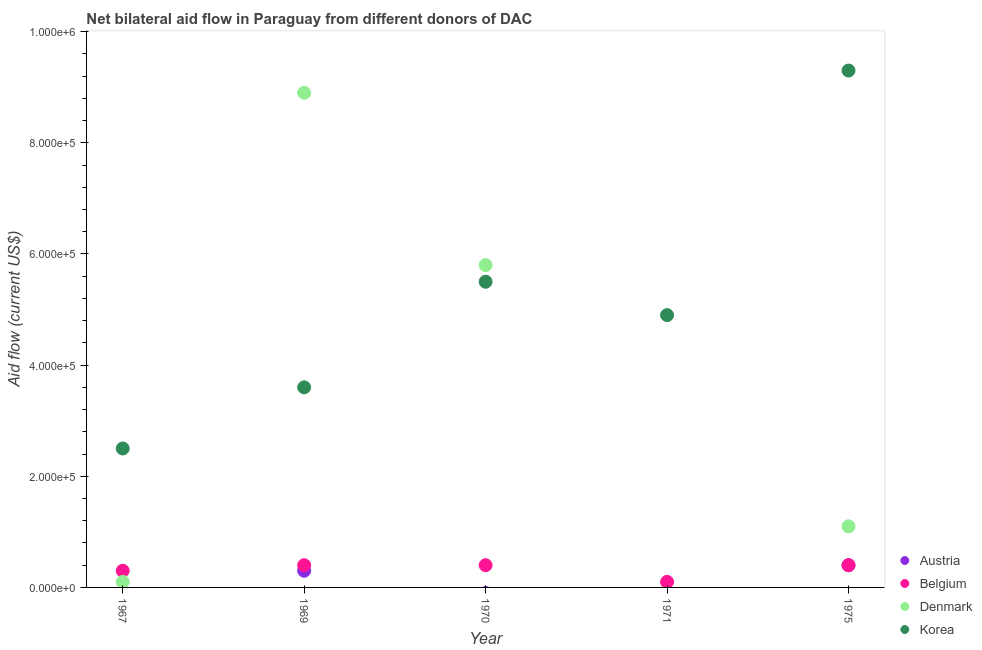What is the amount of aid given by denmark in 1967?
Keep it short and to the point. 10000. Across all years, what is the maximum amount of aid given by denmark?
Your answer should be compact. 8.90e+05. Across all years, what is the minimum amount of aid given by austria?
Keep it short and to the point. 0. In which year was the amount of aid given by denmark maximum?
Ensure brevity in your answer.  1969. What is the total amount of aid given by korea in the graph?
Provide a succinct answer. 2.58e+06. What is the difference between the amount of aid given by belgium in 1967 and that in 1975?
Offer a terse response. -10000. What is the difference between the amount of aid given by denmark in 1970 and the amount of aid given by belgium in 1971?
Ensure brevity in your answer.  5.70e+05. What is the average amount of aid given by korea per year?
Provide a succinct answer. 5.16e+05. In the year 1971, what is the difference between the amount of aid given by korea and amount of aid given by belgium?
Give a very brief answer. 4.80e+05. What is the ratio of the amount of aid given by denmark in 1969 to that in 1970?
Give a very brief answer. 1.53. Is the amount of aid given by belgium in 1969 less than that in 1971?
Your response must be concise. No. What is the difference between the highest and the lowest amount of aid given by denmark?
Keep it short and to the point. 8.90e+05. In how many years, is the amount of aid given by korea greater than the average amount of aid given by korea taken over all years?
Keep it short and to the point. 2. Is the sum of the amount of aid given by denmark in 1967 and 1975 greater than the maximum amount of aid given by korea across all years?
Provide a short and direct response. No. Is it the case that in every year, the sum of the amount of aid given by korea and amount of aid given by belgium is greater than the sum of amount of aid given by austria and amount of aid given by denmark?
Give a very brief answer. Yes. Is it the case that in every year, the sum of the amount of aid given by austria and amount of aid given by belgium is greater than the amount of aid given by denmark?
Your answer should be compact. No. Does the amount of aid given by korea monotonically increase over the years?
Provide a succinct answer. No. Are the values on the major ticks of Y-axis written in scientific E-notation?
Keep it short and to the point. Yes. Does the graph contain any zero values?
Provide a succinct answer. Yes. How many legend labels are there?
Provide a succinct answer. 4. What is the title of the graph?
Provide a short and direct response. Net bilateral aid flow in Paraguay from different donors of DAC. Does "Switzerland" appear as one of the legend labels in the graph?
Provide a short and direct response. No. What is the label or title of the Y-axis?
Provide a succinct answer. Aid flow (current US$). What is the Aid flow (current US$) in Denmark in 1969?
Your response must be concise. 8.90e+05. What is the Aid flow (current US$) of Korea in 1969?
Give a very brief answer. 3.60e+05. What is the Aid flow (current US$) in Belgium in 1970?
Ensure brevity in your answer.  4.00e+04. What is the Aid flow (current US$) in Denmark in 1970?
Provide a short and direct response. 5.80e+05. What is the Aid flow (current US$) of Korea in 1970?
Your answer should be very brief. 5.50e+05. What is the Aid flow (current US$) in Austria in 1971?
Offer a terse response. 0. What is the Aid flow (current US$) of Austria in 1975?
Your response must be concise. 4.00e+04. What is the Aid flow (current US$) in Belgium in 1975?
Offer a terse response. 4.00e+04. What is the Aid flow (current US$) of Denmark in 1975?
Provide a succinct answer. 1.10e+05. What is the Aid flow (current US$) of Korea in 1975?
Your answer should be compact. 9.30e+05. Across all years, what is the maximum Aid flow (current US$) of Denmark?
Give a very brief answer. 8.90e+05. Across all years, what is the maximum Aid flow (current US$) in Korea?
Your response must be concise. 9.30e+05. Across all years, what is the minimum Aid flow (current US$) in Austria?
Ensure brevity in your answer.  0. Across all years, what is the minimum Aid flow (current US$) in Belgium?
Offer a terse response. 10000. What is the total Aid flow (current US$) in Austria in the graph?
Give a very brief answer. 7.00e+04. What is the total Aid flow (current US$) of Denmark in the graph?
Provide a succinct answer. 1.59e+06. What is the total Aid flow (current US$) in Korea in the graph?
Ensure brevity in your answer.  2.58e+06. What is the difference between the Aid flow (current US$) of Belgium in 1967 and that in 1969?
Your answer should be compact. -10000. What is the difference between the Aid flow (current US$) in Denmark in 1967 and that in 1969?
Your answer should be compact. -8.80e+05. What is the difference between the Aid flow (current US$) of Belgium in 1967 and that in 1970?
Offer a terse response. -10000. What is the difference between the Aid flow (current US$) of Denmark in 1967 and that in 1970?
Make the answer very short. -5.70e+05. What is the difference between the Aid flow (current US$) in Belgium in 1967 and that in 1971?
Ensure brevity in your answer.  2.00e+04. What is the difference between the Aid flow (current US$) of Korea in 1967 and that in 1971?
Ensure brevity in your answer.  -2.40e+05. What is the difference between the Aid flow (current US$) in Belgium in 1967 and that in 1975?
Keep it short and to the point. -10000. What is the difference between the Aid flow (current US$) in Denmark in 1967 and that in 1975?
Provide a succinct answer. -1.00e+05. What is the difference between the Aid flow (current US$) of Korea in 1967 and that in 1975?
Your answer should be compact. -6.80e+05. What is the difference between the Aid flow (current US$) in Belgium in 1969 and that in 1970?
Your answer should be very brief. 0. What is the difference between the Aid flow (current US$) in Denmark in 1969 and that in 1970?
Your answer should be very brief. 3.10e+05. What is the difference between the Aid flow (current US$) in Austria in 1969 and that in 1975?
Ensure brevity in your answer.  -10000. What is the difference between the Aid flow (current US$) in Denmark in 1969 and that in 1975?
Your response must be concise. 7.80e+05. What is the difference between the Aid flow (current US$) in Korea in 1969 and that in 1975?
Offer a terse response. -5.70e+05. What is the difference between the Aid flow (current US$) of Denmark in 1970 and that in 1975?
Keep it short and to the point. 4.70e+05. What is the difference between the Aid flow (current US$) in Korea in 1970 and that in 1975?
Ensure brevity in your answer.  -3.80e+05. What is the difference between the Aid flow (current US$) in Korea in 1971 and that in 1975?
Give a very brief answer. -4.40e+05. What is the difference between the Aid flow (current US$) of Belgium in 1967 and the Aid flow (current US$) of Denmark in 1969?
Keep it short and to the point. -8.60e+05. What is the difference between the Aid flow (current US$) of Belgium in 1967 and the Aid flow (current US$) of Korea in 1969?
Your answer should be compact. -3.30e+05. What is the difference between the Aid flow (current US$) of Denmark in 1967 and the Aid flow (current US$) of Korea in 1969?
Make the answer very short. -3.50e+05. What is the difference between the Aid flow (current US$) in Belgium in 1967 and the Aid flow (current US$) in Denmark in 1970?
Give a very brief answer. -5.50e+05. What is the difference between the Aid flow (current US$) of Belgium in 1967 and the Aid flow (current US$) of Korea in 1970?
Make the answer very short. -5.20e+05. What is the difference between the Aid flow (current US$) of Denmark in 1967 and the Aid flow (current US$) of Korea in 1970?
Keep it short and to the point. -5.40e+05. What is the difference between the Aid flow (current US$) in Belgium in 1967 and the Aid flow (current US$) in Korea in 1971?
Your answer should be very brief. -4.60e+05. What is the difference between the Aid flow (current US$) of Denmark in 1967 and the Aid flow (current US$) of Korea in 1971?
Make the answer very short. -4.80e+05. What is the difference between the Aid flow (current US$) in Belgium in 1967 and the Aid flow (current US$) in Korea in 1975?
Ensure brevity in your answer.  -9.00e+05. What is the difference between the Aid flow (current US$) in Denmark in 1967 and the Aid flow (current US$) in Korea in 1975?
Your answer should be compact. -9.20e+05. What is the difference between the Aid flow (current US$) in Austria in 1969 and the Aid flow (current US$) in Belgium in 1970?
Provide a succinct answer. -10000. What is the difference between the Aid flow (current US$) in Austria in 1969 and the Aid flow (current US$) in Denmark in 1970?
Make the answer very short. -5.50e+05. What is the difference between the Aid flow (current US$) in Austria in 1969 and the Aid flow (current US$) in Korea in 1970?
Keep it short and to the point. -5.20e+05. What is the difference between the Aid flow (current US$) of Belgium in 1969 and the Aid flow (current US$) of Denmark in 1970?
Give a very brief answer. -5.40e+05. What is the difference between the Aid flow (current US$) in Belgium in 1969 and the Aid flow (current US$) in Korea in 1970?
Offer a very short reply. -5.10e+05. What is the difference between the Aid flow (current US$) of Denmark in 1969 and the Aid flow (current US$) of Korea in 1970?
Make the answer very short. 3.40e+05. What is the difference between the Aid flow (current US$) of Austria in 1969 and the Aid flow (current US$) of Belgium in 1971?
Provide a short and direct response. 2.00e+04. What is the difference between the Aid flow (current US$) in Austria in 1969 and the Aid flow (current US$) in Korea in 1971?
Make the answer very short. -4.60e+05. What is the difference between the Aid flow (current US$) in Belgium in 1969 and the Aid flow (current US$) in Korea in 1971?
Make the answer very short. -4.50e+05. What is the difference between the Aid flow (current US$) of Denmark in 1969 and the Aid flow (current US$) of Korea in 1971?
Your answer should be very brief. 4.00e+05. What is the difference between the Aid flow (current US$) of Austria in 1969 and the Aid flow (current US$) of Belgium in 1975?
Provide a succinct answer. -10000. What is the difference between the Aid flow (current US$) of Austria in 1969 and the Aid flow (current US$) of Korea in 1975?
Your answer should be compact. -9.00e+05. What is the difference between the Aid flow (current US$) of Belgium in 1969 and the Aid flow (current US$) of Korea in 1975?
Your answer should be very brief. -8.90e+05. What is the difference between the Aid flow (current US$) of Belgium in 1970 and the Aid flow (current US$) of Korea in 1971?
Keep it short and to the point. -4.50e+05. What is the difference between the Aid flow (current US$) of Denmark in 1970 and the Aid flow (current US$) of Korea in 1971?
Offer a terse response. 9.00e+04. What is the difference between the Aid flow (current US$) in Belgium in 1970 and the Aid flow (current US$) in Denmark in 1975?
Provide a short and direct response. -7.00e+04. What is the difference between the Aid flow (current US$) in Belgium in 1970 and the Aid flow (current US$) in Korea in 1975?
Your answer should be very brief. -8.90e+05. What is the difference between the Aid flow (current US$) of Denmark in 1970 and the Aid flow (current US$) of Korea in 1975?
Offer a terse response. -3.50e+05. What is the difference between the Aid flow (current US$) of Belgium in 1971 and the Aid flow (current US$) of Denmark in 1975?
Offer a very short reply. -1.00e+05. What is the difference between the Aid flow (current US$) of Belgium in 1971 and the Aid flow (current US$) of Korea in 1975?
Ensure brevity in your answer.  -9.20e+05. What is the average Aid flow (current US$) of Austria per year?
Your answer should be very brief. 1.40e+04. What is the average Aid flow (current US$) of Belgium per year?
Give a very brief answer. 3.20e+04. What is the average Aid flow (current US$) of Denmark per year?
Provide a succinct answer. 3.18e+05. What is the average Aid flow (current US$) of Korea per year?
Ensure brevity in your answer.  5.16e+05. In the year 1967, what is the difference between the Aid flow (current US$) in Belgium and Aid flow (current US$) in Denmark?
Provide a succinct answer. 2.00e+04. In the year 1969, what is the difference between the Aid flow (current US$) in Austria and Aid flow (current US$) in Denmark?
Your response must be concise. -8.60e+05. In the year 1969, what is the difference between the Aid flow (current US$) of Austria and Aid flow (current US$) of Korea?
Give a very brief answer. -3.30e+05. In the year 1969, what is the difference between the Aid flow (current US$) in Belgium and Aid flow (current US$) in Denmark?
Give a very brief answer. -8.50e+05. In the year 1969, what is the difference between the Aid flow (current US$) of Belgium and Aid flow (current US$) of Korea?
Offer a very short reply. -3.20e+05. In the year 1969, what is the difference between the Aid flow (current US$) of Denmark and Aid flow (current US$) of Korea?
Your answer should be very brief. 5.30e+05. In the year 1970, what is the difference between the Aid flow (current US$) of Belgium and Aid flow (current US$) of Denmark?
Provide a short and direct response. -5.40e+05. In the year 1970, what is the difference between the Aid flow (current US$) of Belgium and Aid flow (current US$) of Korea?
Offer a terse response. -5.10e+05. In the year 1971, what is the difference between the Aid flow (current US$) in Belgium and Aid flow (current US$) in Korea?
Your answer should be very brief. -4.80e+05. In the year 1975, what is the difference between the Aid flow (current US$) of Austria and Aid flow (current US$) of Belgium?
Offer a very short reply. 0. In the year 1975, what is the difference between the Aid flow (current US$) of Austria and Aid flow (current US$) of Korea?
Keep it short and to the point. -8.90e+05. In the year 1975, what is the difference between the Aid flow (current US$) in Belgium and Aid flow (current US$) in Denmark?
Your response must be concise. -7.00e+04. In the year 1975, what is the difference between the Aid flow (current US$) of Belgium and Aid flow (current US$) of Korea?
Provide a short and direct response. -8.90e+05. In the year 1975, what is the difference between the Aid flow (current US$) of Denmark and Aid flow (current US$) of Korea?
Keep it short and to the point. -8.20e+05. What is the ratio of the Aid flow (current US$) of Belgium in 1967 to that in 1969?
Your answer should be very brief. 0.75. What is the ratio of the Aid flow (current US$) of Denmark in 1967 to that in 1969?
Provide a succinct answer. 0.01. What is the ratio of the Aid flow (current US$) in Korea in 1967 to that in 1969?
Provide a short and direct response. 0.69. What is the ratio of the Aid flow (current US$) of Belgium in 1967 to that in 1970?
Make the answer very short. 0.75. What is the ratio of the Aid flow (current US$) in Denmark in 1967 to that in 1970?
Your response must be concise. 0.02. What is the ratio of the Aid flow (current US$) of Korea in 1967 to that in 1970?
Provide a succinct answer. 0.45. What is the ratio of the Aid flow (current US$) in Korea in 1967 to that in 1971?
Give a very brief answer. 0.51. What is the ratio of the Aid flow (current US$) in Belgium in 1967 to that in 1975?
Your answer should be compact. 0.75. What is the ratio of the Aid flow (current US$) in Denmark in 1967 to that in 1975?
Offer a very short reply. 0.09. What is the ratio of the Aid flow (current US$) of Korea in 1967 to that in 1975?
Provide a succinct answer. 0.27. What is the ratio of the Aid flow (current US$) of Denmark in 1969 to that in 1970?
Make the answer very short. 1.53. What is the ratio of the Aid flow (current US$) in Korea in 1969 to that in 1970?
Your answer should be compact. 0.65. What is the ratio of the Aid flow (current US$) of Korea in 1969 to that in 1971?
Your response must be concise. 0.73. What is the ratio of the Aid flow (current US$) of Denmark in 1969 to that in 1975?
Give a very brief answer. 8.09. What is the ratio of the Aid flow (current US$) of Korea in 1969 to that in 1975?
Offer a terse response. 0.39. What is the ratio of the Aid flow (current US$) of Belgium in 1970 to that in 1971?
Give a very brief answer. 4. What is the ratio of the Aid flow (current US$) in Korea in 1970 to that in 1971?
Make the answer very short. 1.12. What is the ratio of the Aid flow (current US$) in Belgium in 1970 to that in 1975?
Provide a succinct answer. 1. What is the ratio of the Aid flow (current US$) of Denmark in 1970 to that in 1975?
Keep it short and to the point. 5.27. What is the ratio of the Aid flow (current US$) of Korea in 1970 to that in 1975?
Your answer should be compact. 0.59. What is the ratio of the Aid flow (current US$) of Korea in 1971 to that in 1975?
Provide a short and direct response. 0.53. What is the difference between the highest and the second highest Aid flow (current US$) in Denmark?
Provide a short and direct response. 3.10e+05. What is the difference between the highest and the lowest Aid flow (current US$) of Austria?
Your response must be concise. 4.00e+04. What is the difference between the highest and the lowest Aid flow (current US$) of Belgium?
Your answer should be very brief. 3.00e+04. What is the difference between the highest and the lowest Aid flow (current US$) in Denmark?
Make the answer very short. 8.90e+05. What is the difference between the highest and the lowest Aid flow (current US$) in Korea?
Provide a short and direct response. 6.80e+05. 